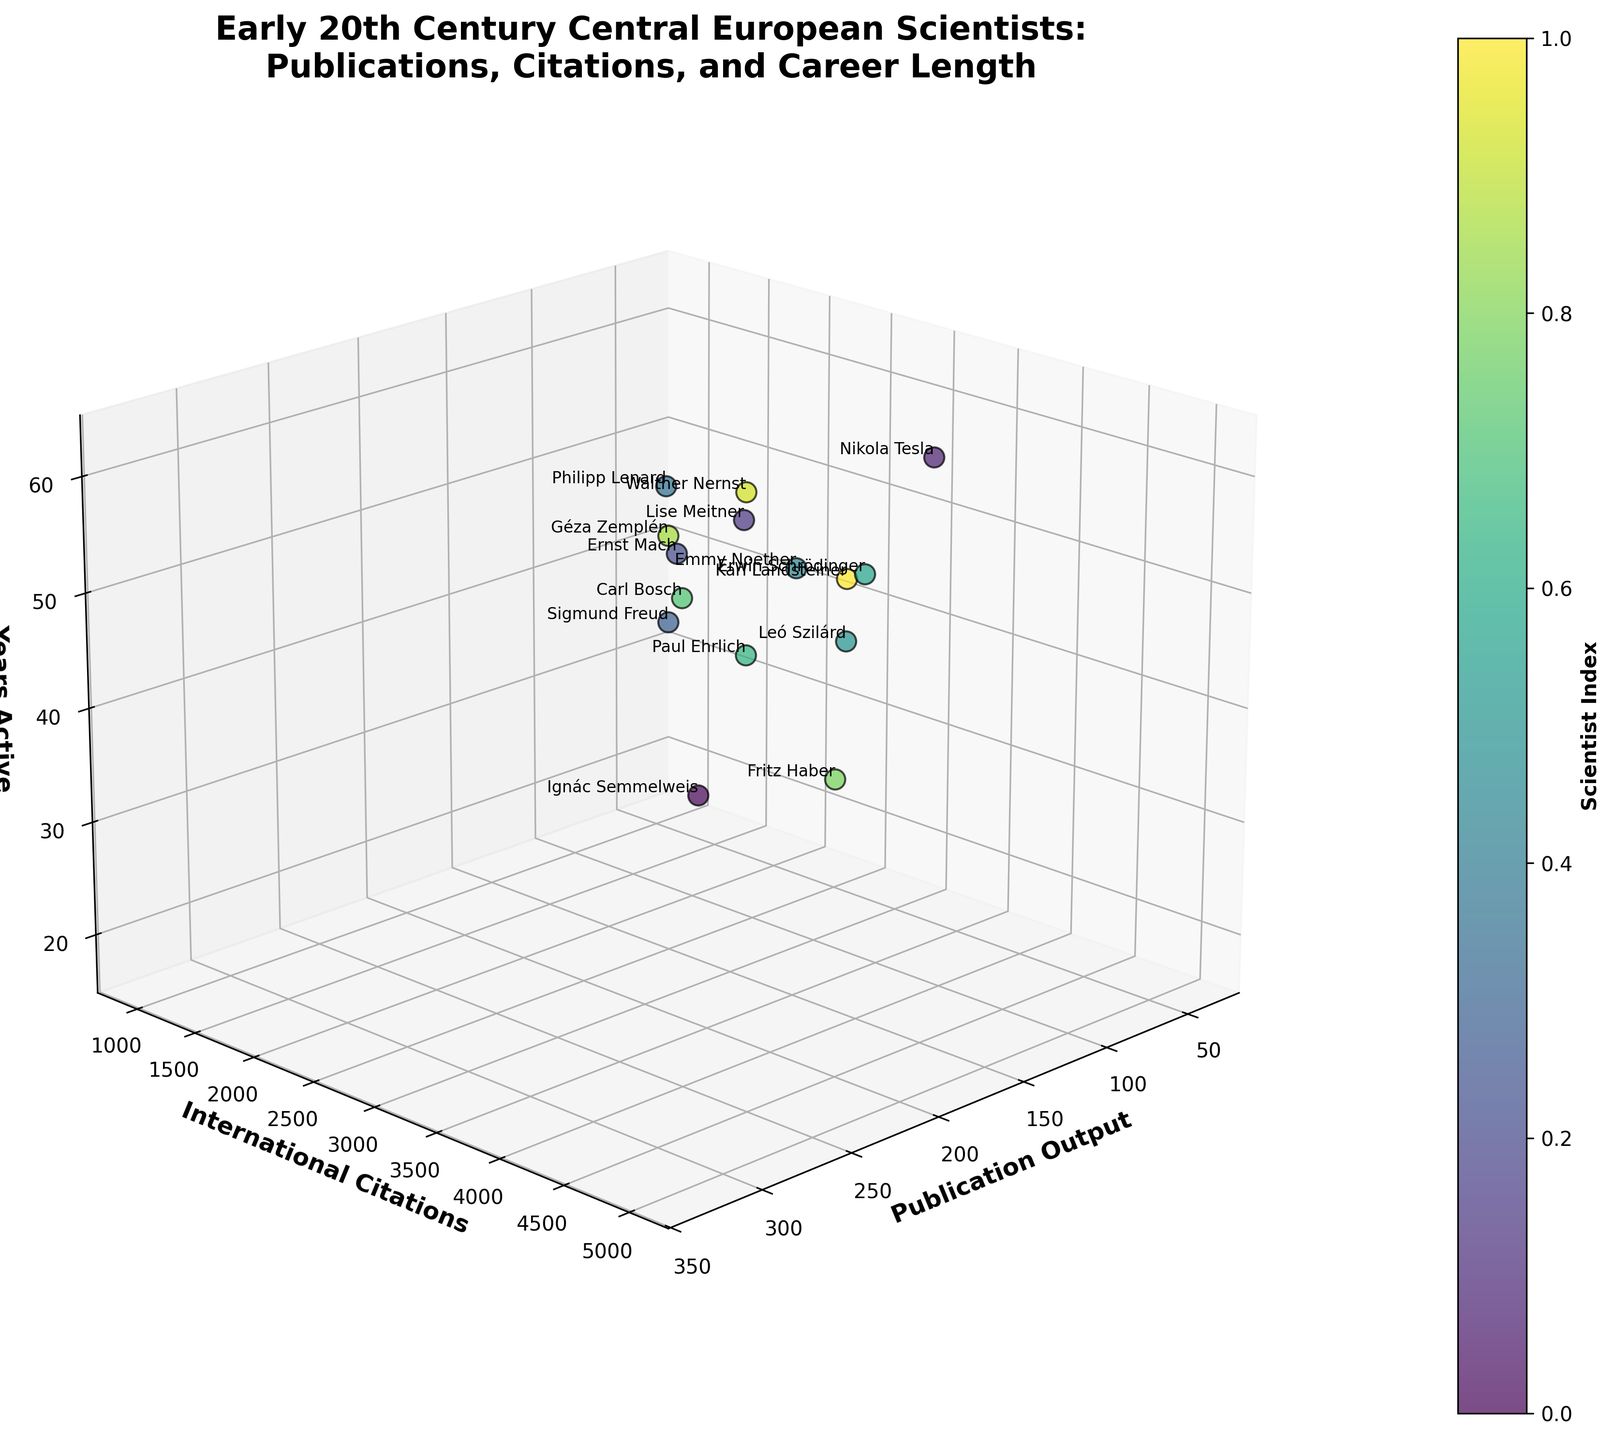What's the title of the figure? The title is usually the text placed at the top of the figure. For this specific plot, it should describe the content it depicts.
Answer: Early 20th Century Central European Scientists: Publications, Citations, and Career Length Which scientist has the highest publication output? To find this, look for the data point that is farthest to the right on the x-axis (Publication Output).
Answer: Sigmund Freud Which scientist has the highest number of international citations? Locate the data point that is highest on the y-axis (International Citations).
Answer: Sigmund Freud Which scientist was active for the longest time? Identify the data point that is farthest along the z-axis (Years Active).
Answer: Sigmund Freud Which scientist has the lowest number of international citations? Look for the data point closest to the origin on the y-axis (International Citations).
Answer: Géza Zemplén Which two scientists have the closest publication output? Find two data points that are nearest to each other along the x-axis (Publication Output).
Answer: Carl Bosch and Nikola Tesla Who has a higher number of international citations, Erwin Schrödinger or Paul Ehrlich? Compare the positions of these scientists' data points on the y-axis (International Citations).
Answer: Erwin Schrödinger What's the total number of years active for Lise Meitner and Ernst Mach? Add the years active for both Lise Meitner and Ernst Mach from the z-axis values.
Answer: 98 What's the difference in the number of international citations between Nikola Tesla and Leó Szilárd? Subtract the international citations of Leó Szilárd from the international citations of Nikola Tesla using their y-axis values.
Answer: 600 Which scientist with more than 100 publication outputs has the second-highest number of international citations? Filter out scientists with more than 100 publication outputs first. Then, among those, find the one with the second-highest y-axis value.
Answer: Paul Ehrlich 